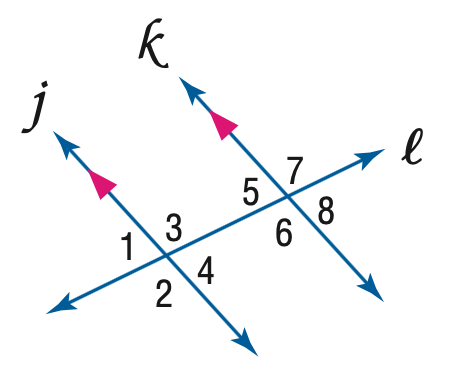Question: If m \angle 2 = 4 x + 7 and m \angle 7 = 5 x - 13, find x.
Choices:
A. 6
B. 19
C. 20
D. 21
Answer with the letter. Answer: C 